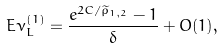<formula> <loc_0><loc_0><loc_500><loc_500>E \nu _ { L } ^ { ( 1 ) } = \frac { e ^ { 2 C / \widetilde { \rho } _ { 1 , 2 } } - 1 } { \delta } + O ( 1 ) ,</formula> 